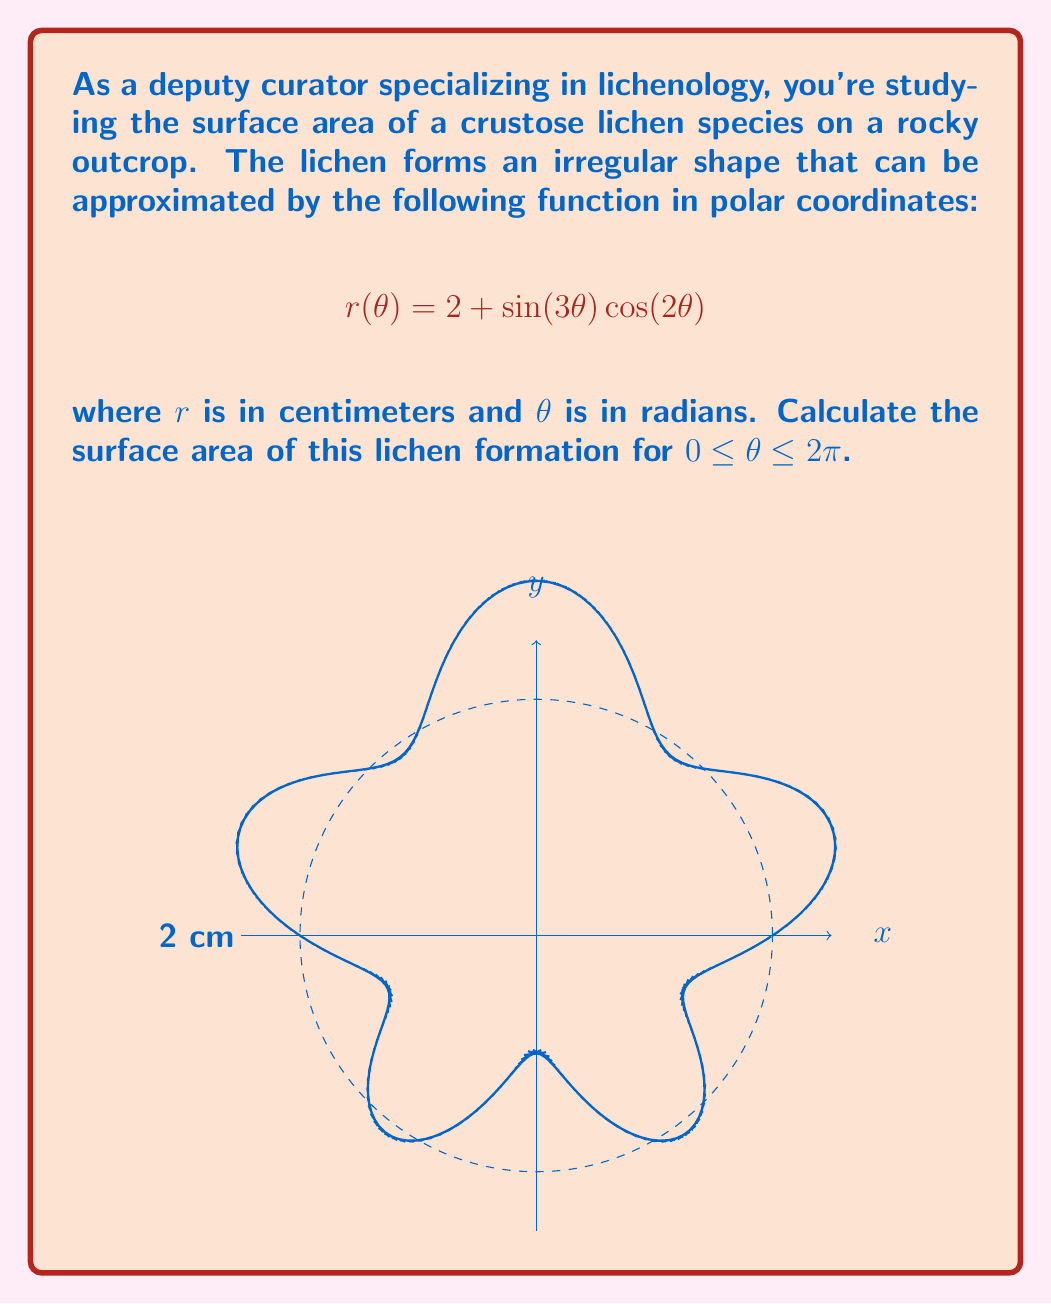Provide a solution to this math problem. To calculate the surface area of this irregular lichen formation, we'll use the formula for the area of a region in polar coordinates:

$$A = \frac{1}{2} \int_0^{2\pi} [r(\theta)]^2 d\theta$$

Steps:
1) First, we square the given function:
   $$[r(\theta)]^2 = (2 + \sin(3\theta) \cos(2\theta))^2$$
   $$= 4 + 4\sin(3\theta) \cos(2\theta) + \sin^2(3\theta) \cos^2(2\theta)$$

2) Now, we integrate this function from 0 to 2π:
   $$A = \frac{1}{2} \int_0^{2\pi} (4 + 4\sin(3\theta) \cos(2\theta) + \sin^2(3\theta) \cos^2(2\theta)) d\theta$$

3) We can break this into three integrals:
   $$A = \frac{1}{2} \left[ 4 \int_0^{2\pi} d\theta + 4 \int_0^{2\pi} \sin(3\theta) \cos(2\theta) d\theta + \int_0^{2\pi} \sin^2(3\theta) \cos^2(2\theta) d\theta \right]$$

4) Evaluate each integral:
   - $\int_0^{2\pi} d\theta = 2\pi$
   - $\int_0^{2\pi} \sin(3\theta) \cos(2\theta) d\theta = 0$ (because it's the integral of an odd function over a symmetric interval)
   - $\int_0^{2\pi} \sin^2(3\theta) \cos^2(2\theta) d\theta = \frac{\pi}{2}$ (this can be shown using trigonometric identities and integration)

5) Substituting these results:
   $$A = \frac{1}{2} \left[ 4(2\pi) + 4(0) + \frac{\pi}{2} \right] = 4\pi + \frac{\pi}{4} = \frac{17\pi}{4}$$

6) Therefore, the surface area of the lichen formation is $\frac{17\pi}{4}$ square centimeters.
Answer: $\frac{17\pi}{4}$ cm² 